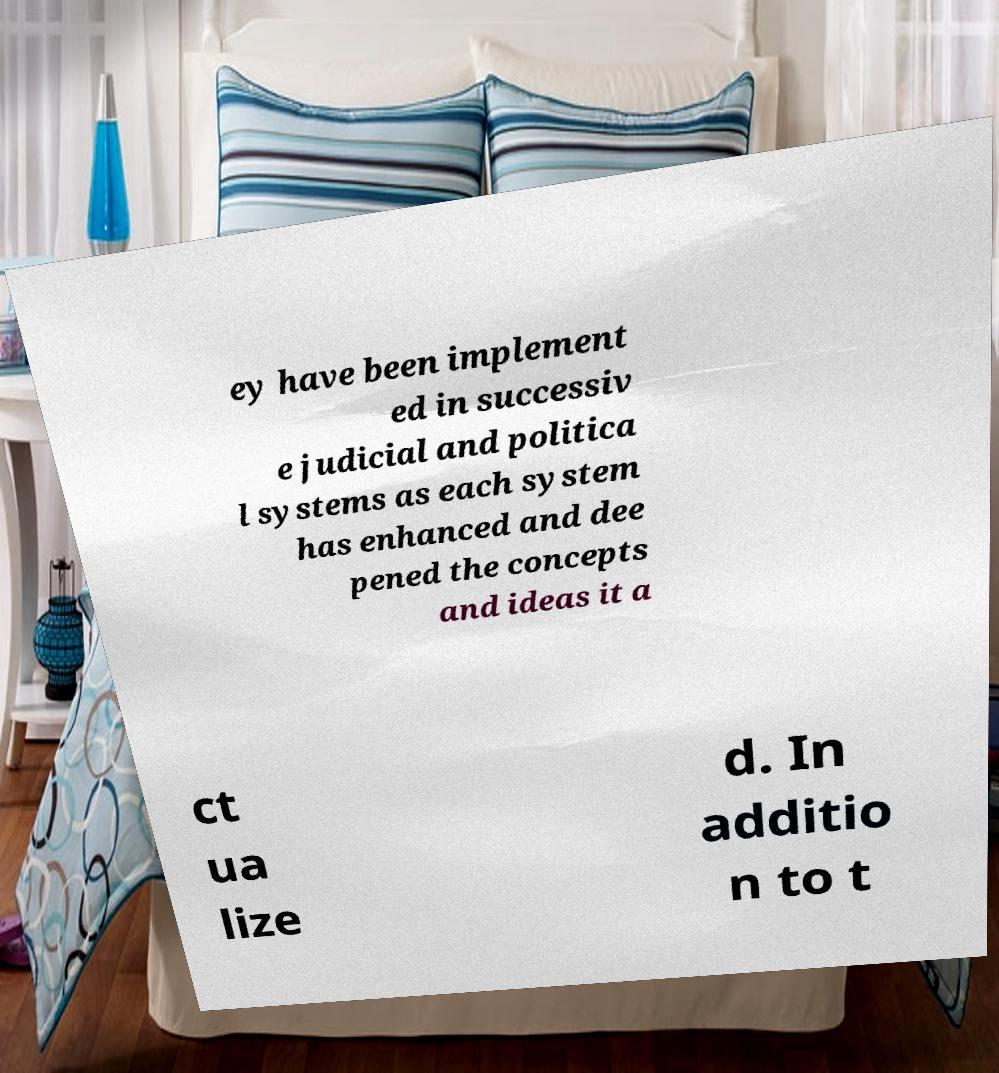Can you read and provide the text displayed in the image?This photo seems to have some interesting text. Can you extract and type it out for me? ey have been implement ed in successiv e judicial and politica l systems as each system has enhanced and dee pened the concepts and ideas it a ct ua lize d. In additio n to t 